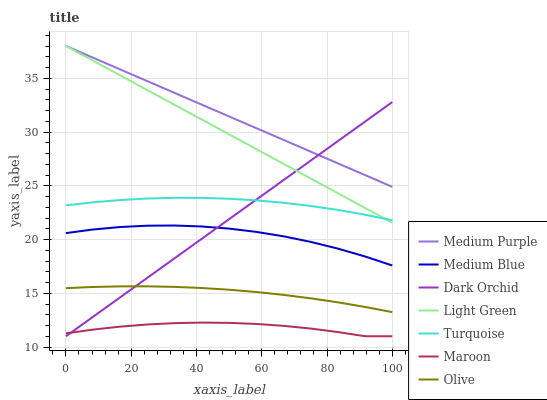Does Maroon have the minimum area under the curve?
Answer yes or no. Yes. Does Medium Purple have the maximum area under the curve?
Answer yes or no. Yes. Does Medium Blue have the minimum area under the curve?
Answer yes or no. No. Does Medium Blue have the maximum area under the curve?
Answer yes or no. No. Is Light Green the smoothest?
Answer yes or no. Yes. Is Medium Blue the roughest?
Answer yes or no. Yes. Is Maroon the smoothest?
Answer yes or no. No. Is Maroon the roughest?
Answer yes or no. No. Does Maroon have the lowest value?
Answer yes or no. Yes. Does Medium Blue have the lowest value?
Answer yes or no. No. Does Light Green have the highest value?
Answer yes or no. Yes. Does Medium Blue have the highest value?
Answer yes or no. No. Is Olive less than Turquoise?
Answer yes or no. Yes. Is Turquoise greater than Maroon?
Answer yes or no. Yes. Does Dark Orchid intersect Turquoise?
Answer yes or no. Yes. Is Dark Orchid less than Turquoise?
Answer yes or no. No. Is Dark Orchid greater than Turquoise?
Answer yes or no. No. Does Olive intersect Turquoise?
Answer yes or no. No. 